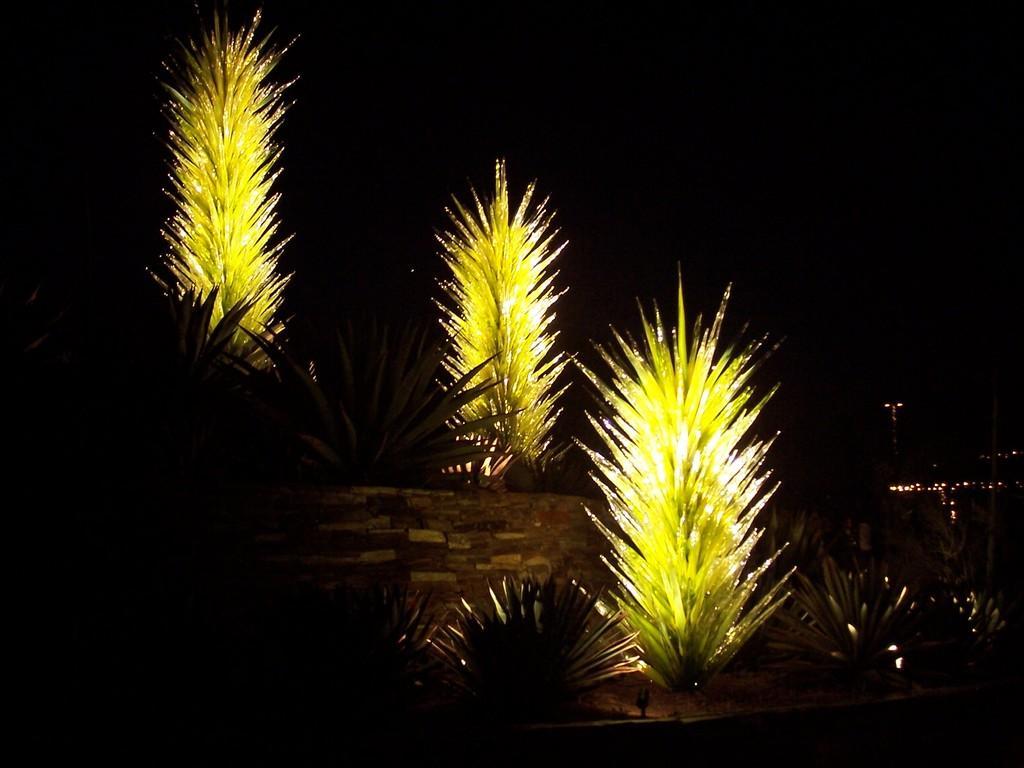Could you give a brief overview of what you see in this image? In this picture we can see trees, wall, lights and in the background it is dark. 